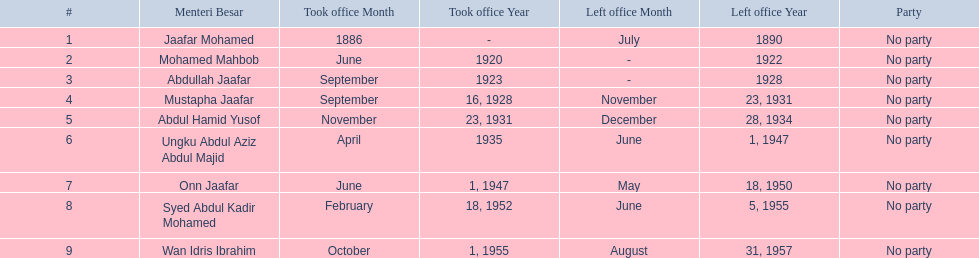Who are all of the menteri besars? Jaafar Mohamed, Mohamed Mahbob, Abdullah Jaafar, Mustapha Jaafar, Abdul Hamid Yusof, Ungku Abdul Aziz Abdul Majid, Onn Jaafar, Syed Abdul Kadir Mohamed, Wan Idris Ibrahim. When did each take office? 1886, June 1920, September 1923, September 16, 1928, November 23, 1931, April 1935, June 1, 1947, February 18, 1952, October 1, 1955. When did they leave? July 1890, 1922, 1928, November 23, 1931, December 28, 1934, June 1, 1947, May 18, 1950, June 5, 1955, August 31, 1957. And which spent the most time in office? Ungku Abdul Aziz Abdul Majid. 